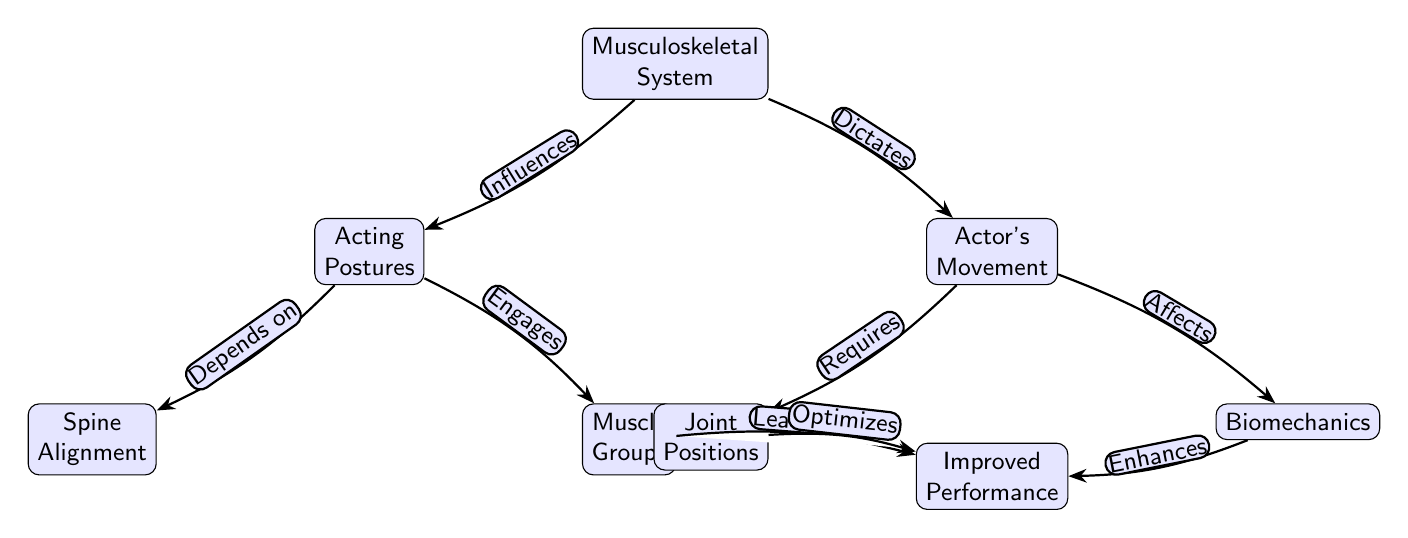What is the top node of the diagram? The top node, which serves as the starting point of the diagram, is labeled "Musculoskeletal System." It's the primary focus on which all other nodes build.
Answer: Musculoskeletal System How many total nodes are in the diagram? By counting all the individual nodes present in the diagram, I find there are a total of 8 nodes listed, including the top node and the 7 subordinate nodes.
Answer: 8 What type of relationship exists between "Musculoskeletal System" and "Actor's Movement"? The relationship defined here is a dictatorial influence, where the musculoskeletal system directly dictates how the actor moves, showing a strong dependency.
Answer: Dictates What does "Joint Positions" require? "Joint Positions" is connected to "Actor's Movement" with a label that states it is required for movement, indicating it is essential for how the actor moves.
Answer: Requires Which node affects "Improved Performance"? The node labeled "Biomechanics" has a relationship specified as affecting "Improved Performance," showcasing how the mechanics of the body influence performance quality in acting.
Answer: Affects In what way does "Muscle Groups" impact performance? The node "Muscle Groups" leads to "Improved Performance," suggesting that the functioning and engagement of these groups are crucial for enhancing performance capabilities.
Answer: Leads to What influences "Acting Postures"? The influence on "Acting Postures" comes from the "Musculoskeletal System," indicating that the way one holds their body while acting is directly driven by the physical structure of the musculoskeletal system.
Answer: Influences Which nodes are positioned directly under "Acting Postures"? Directly beneath "Acting Postures" are two nodes: "Spine Alignment" and "Muscle Groups," both of which are critical elements of how posture is maintained and engaged in acting.
Answer: Spine Alignment, Muscle Groups How does "Joint Positions" relate to "Improved Performance"? "Joint Positions" optimizes "Improved Performance," showing that the positioning of joints plays a significant role in how well an actor can perform, connecting anatomical structure with performance capability.
Answer: Optimizes 